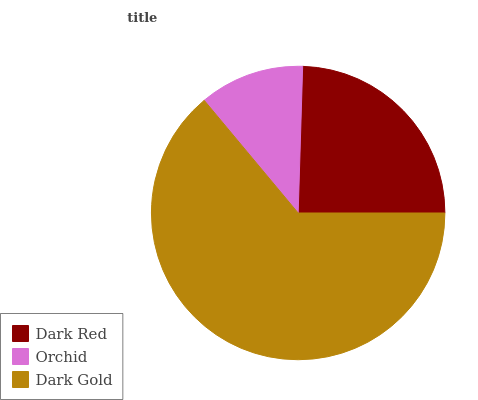Is Orchid the minimum?
Answer yes or no. Yes. Is Dark Gold the maximum?
Answer yes or no. Yes. Is Dark Gold the minimum?
Answer yes or no. No. Is Orchid the maximum?
Answer yes or no. No. Is Dark Gold greater than Orchid?
Answer yes or no. Yes. Is Orchid less than Dark Gold?
Answer yes or no. Yes. Is Orchid greater than Dark Gold?
Answer yes or no. No. Is Dark Gold less than Orchid?
Answer yes or no. No. Is Dark Red the high median?
Answer yes or no. Yes. Is Dark Red the low median?
Answer yes or no. Yes. Is Dark Gold the high median?
Answer yes or no. No. Is Orchid the low median?
Answer yes or no. No. 